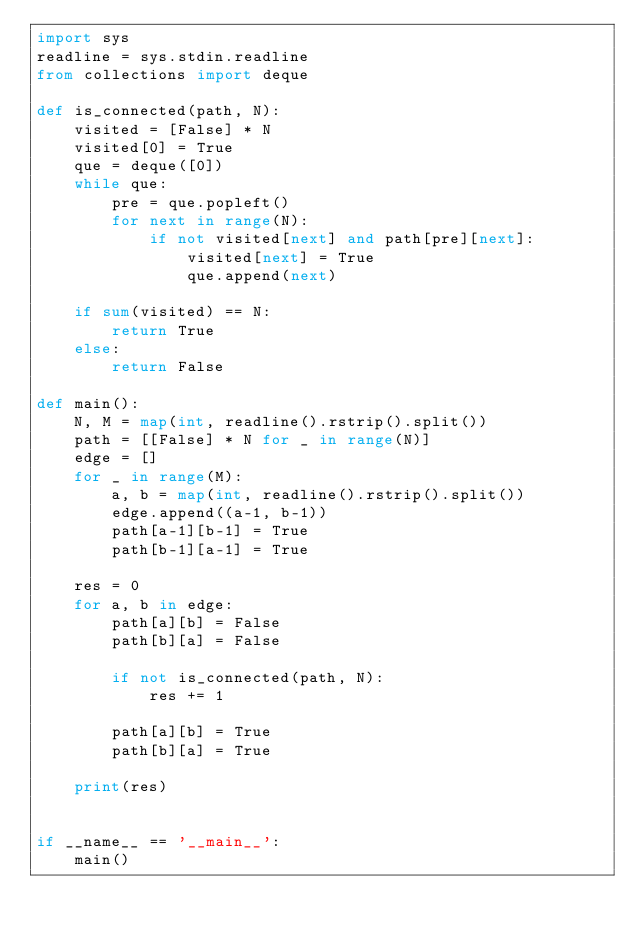<code> <loc_0><loc_0><loc_500><loc_500><_Python_>import sys
readline = sys.stdin.readline
from collections import deque

def is_connected(path, N):
    visited = [False] * N
    visited[0] = True
    que = deque([0])
    while que:
        pre = que.popleft()
        for next in range(N):
            if not visited[next] and path[pre][next]:
                visited[next] = True
                que.append(next)
    
    if sum(visited) == N:
        return True
    else:
        return False

def main():
    N, M = map(int, readline().rstrip().split())
    path = [[False] * N for _ in range(N)]
    edge = []
    for _ in range(M):
        a, b = map(int, readline().rstrip().split())
        edge.append((a-1, b-1))
        path[a-1][b-1] = True
        path[b-1][a-1] = True
    
    res = 0
    for a, b in edge:
        path[a][b] = False
        path[b][a] = False

        if not is_connected(path, N):
            res += 1

        path[a][b] = True
        path[b][a] = True

    print(res)


if __name__ == '__main__':
    main()</code> 